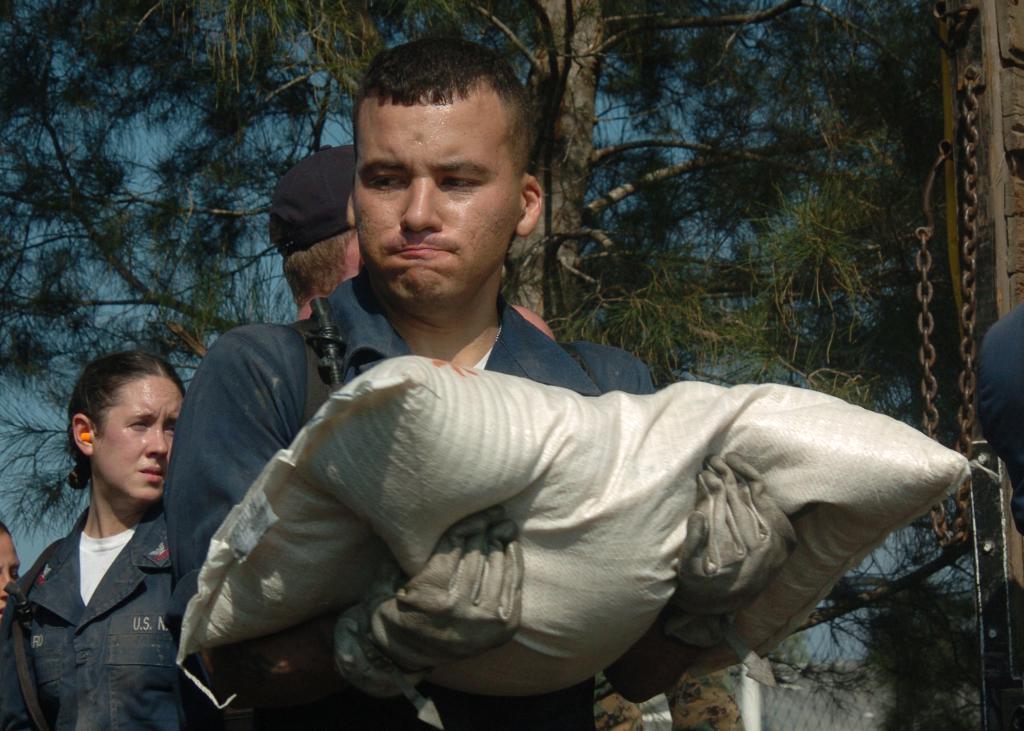How would you summarize this image in a sentence or two? In this image I can see a person wearing black color dress is standing and holding a white colored bag on his hands. In the background I can see few other persons standing, a metal chain, a metal fence, few trees and the sky. 